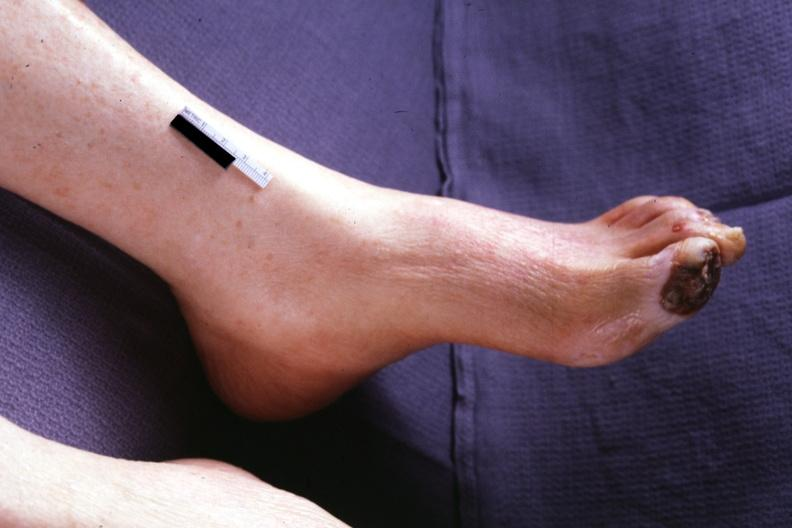does granulomata slide show typical gangrene?
Answer the question using a single word or phrase. No 